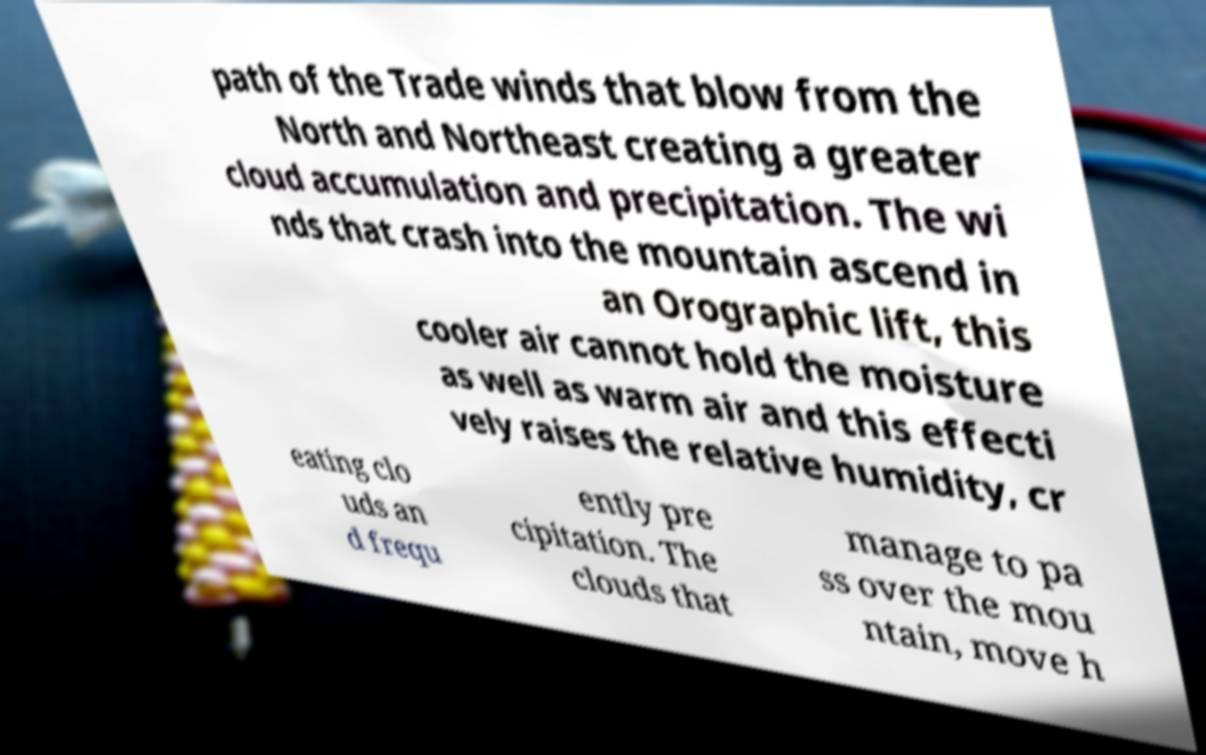Can you read and provide the text displayed in the image?This photo seems to have some interesting text. Can you extract and type it out for me? path of the Trade winds that blow from the North and Northeast creating a greater cloud accumulation and precipitation. The wi nds that crash into the mountain ascend in an Orographic lift, this cooler air cannot hold the moisture as well as warm air and this effecti vely raises the relative humidity, cr eating clo uds an d frequ ently pre cipitation. The clouds that manage to pa ss over the mou ntain, move h 